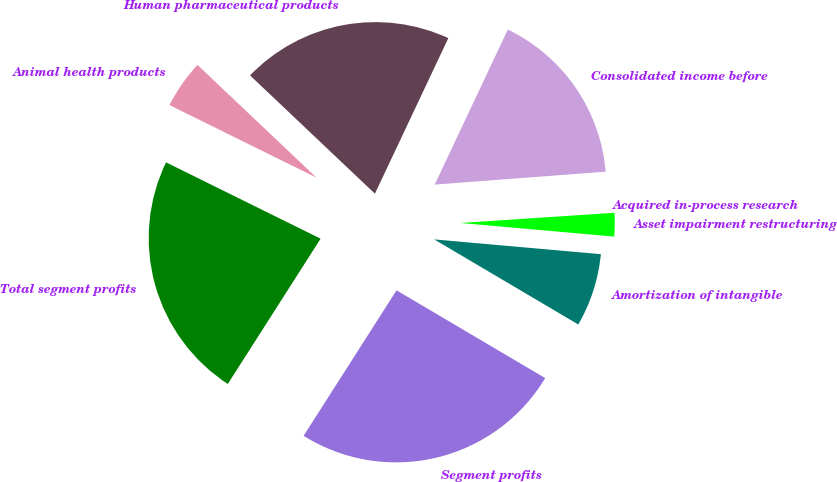<chart> <loc_0><loc_0><loc_500><loc_500><pie_chart><fcel>Human pharmaceutical products<fcel>Animal health products<fcel>Total segment profits<fcel>Segment profits<fcel>Amortization of intangible<fcel>Asset impairment restructuring<fcel>Acquired in-process research<fcel>Consolidated income before<nl><fcel>19.95%<fcel>4.77%<fcel>23.25%<fcel>25.56%<fcel>7.08%<fcel>2.46%<fcel>0.15%<fcel>16.78%<nl></chart> 